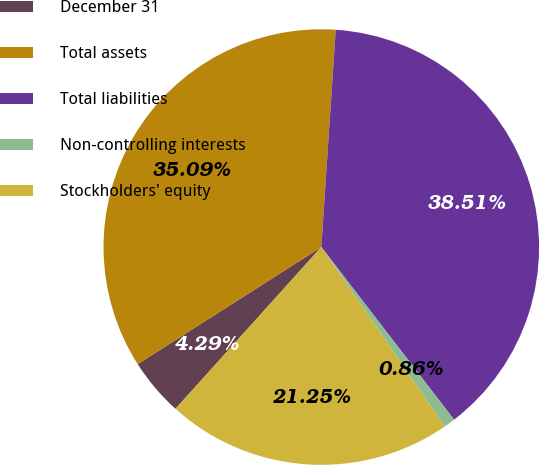Convert chart to OTSL. <chart><loc_0><loc_0><loc_500><loc_500><pie_chart><fcel>December 31<fcel>Total assets<fcel>Total liabilities<fcel>Non-controlling interests<fcel>Stockholders' equity<nl><fcel>4.29%<fcel>35.09%<fcel>38.51%<fcel>0.86%<fcel>21.25%<nl></chart> 